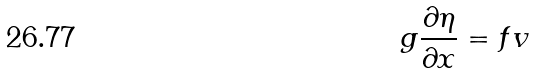<formula> <loc_0><loc_0><loc_500><loc_500>g \frac { \partial \eta } { \partial x } = f v</formula> 